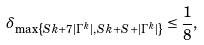Convert formula to latex. <formula><loc_0><loc_0><loc_500><loc_500>\delta _ { \max \left \{ S k + 7 | \Gamma ^ { k } | , { S k + S + | \Gamma ^ { k } | } \right \} } \leq \frac { 1 } { 8 } ,</formula> 